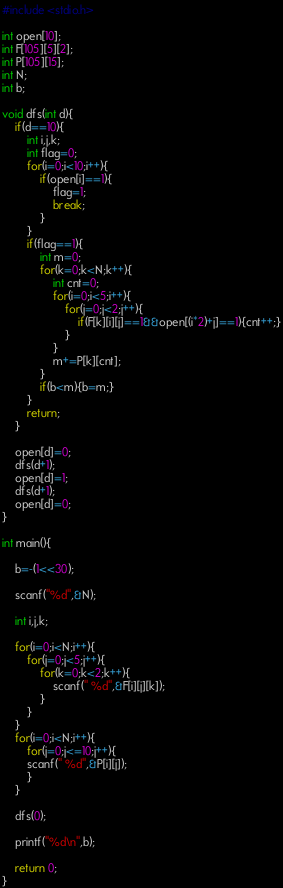<code> <loc_0><loc_0><loc_500><loc_500><_C_>#include <stdio.h>

int open[10];
int F[105][5][2];
int P[105][15];
int N;
int b;

void dfs(int d){
	if(d==10){
		int i,j,k;
		int flag=0;
		for(i=0;i<10;i++){
			if(open[i]==1){
				flag=1;
				break;
			}
		}
		if(flag==1){
			int m=0;
			for(k=0;k<N;k++){
				int cnt=0;
				for(i=0;i<5;i++){
					for(j=0;j<2;j++){
						if(F[k][i][j]==1&&open[(i*2)+j]==1){cnt++;}
					}
				}
				m+=P[k][cnt];
			}
			if(b<m){b=m;}
		}
		return;
	}

	open[d]=0;
	dfs(d+1);
	open[d]=1;
	dfs(d+1);
	open[d]=0;
}

int main(){

	b=-(1<<30);

	scanf("%d",&N);

	int i,j,k;

	for(i=0;i<N;i++){
		for(j=0;j<5;j++){
			for(k=0;k<2;k++){
				scanf(" %d",&F[i][j][k]);
			}
		}
	}
	for(i=0;i<N;i++){
		for(j=0;j<=10;j++){
		scanf(" %d",&P[i][j]);
		}
	}

	dfs(0);

	printf("%d\n",b);

	return 0;
}</code> 